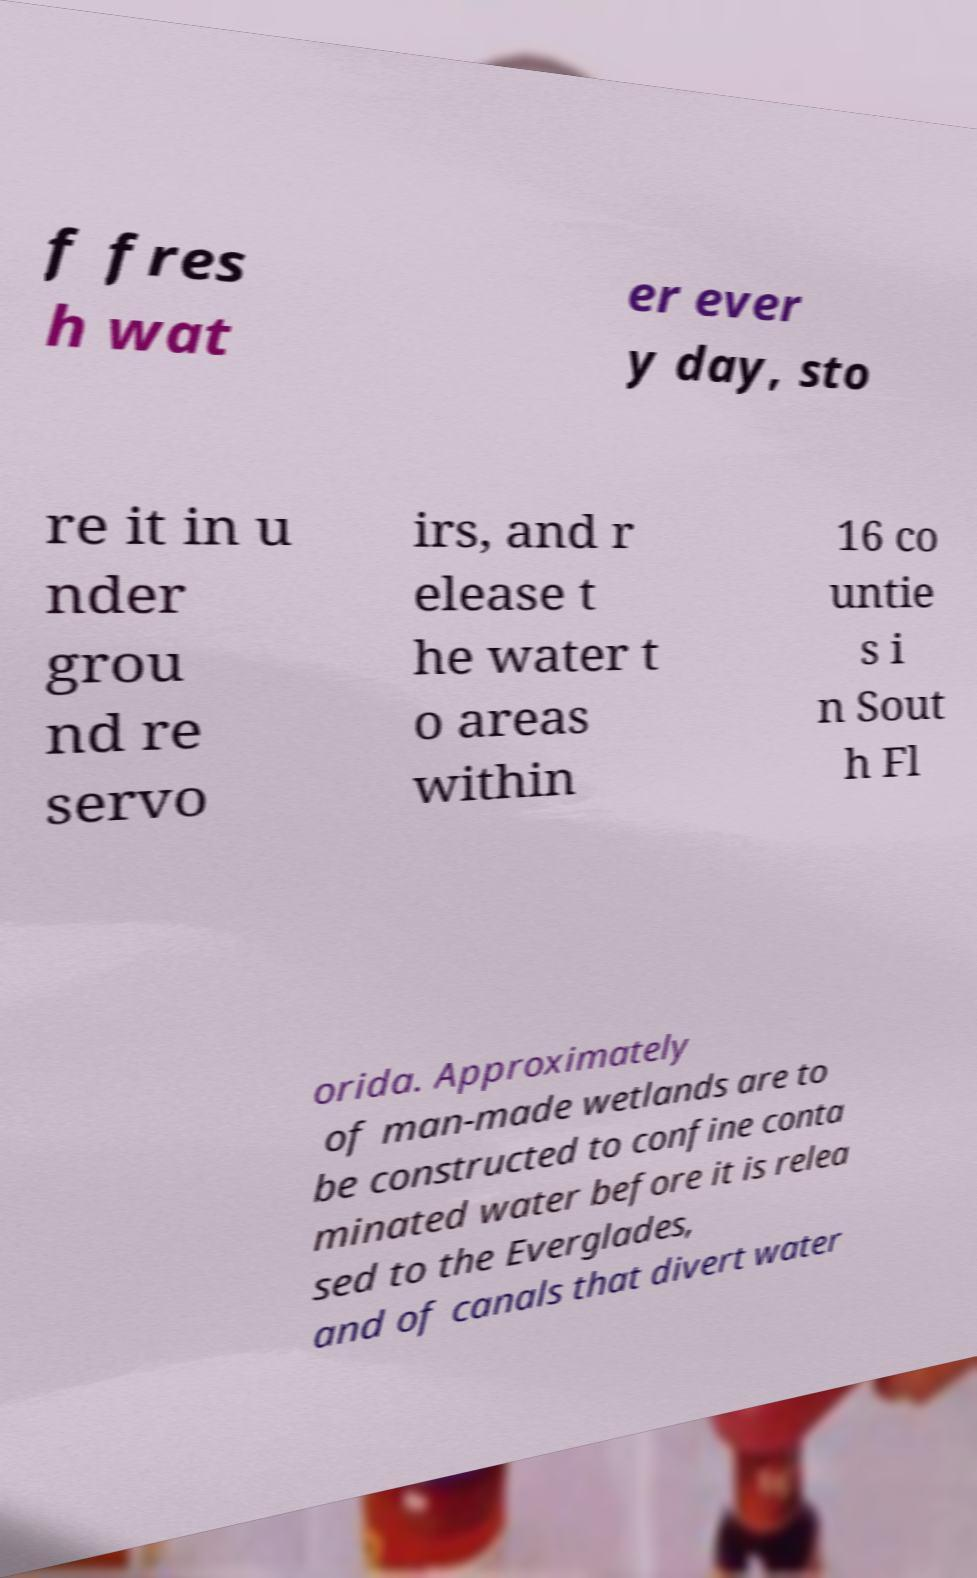Can you accurately transcribe the text from the provided image for me? f fres h wat er ever y day, sto re it in u nder grou nd re servo irs, and r elease t he water t o areas within 16 co untie s i n Sout h Fl orida. Approximately of man-made wetlands are to be constructed to confine conta minated water before it is relea sed to the Everglades, and of canals that divert water 